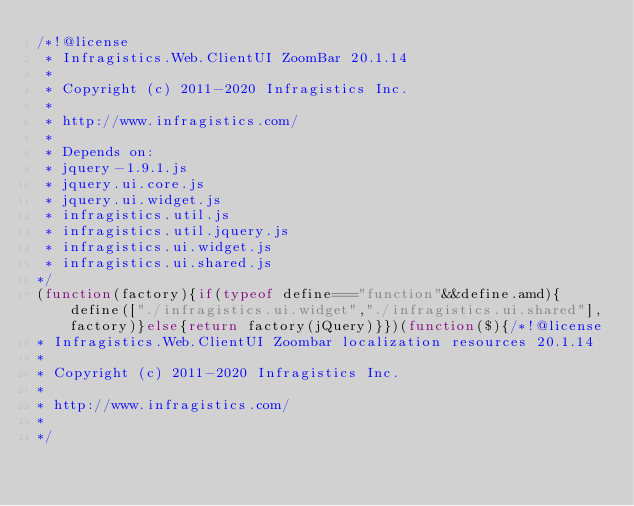Convert code to text. <code><loc_0><loc_0><loc_500><loc_500><_JavaScript_>/*!@license
 * Infragistics.Web.ClientUI ZoomBar 20.1.14
 *
 * Copyright (c) 2011-2020 Infragistics Inc.
 *
 * http://www.infragistics.com/
 *
 * Depends on:
 * jquery-1.9.1.js
 * jquery.ui.core.js
 * jquery.ui.widget.js
 * infragistics.util.js
 * infragistics.util.jquery.js
 * infragistics.ui.widget.js
 * infragistics.ui.shared.js
*/
(function(factory){if(typeof define==="function"&&define.amd){define(["./infragistics.ui.widget","./infragistics.ui.shared"],factory)}else{return factory(jQuery)}})(function($){/*!@license
* Infragistics.Web.ClientUI Zoombar localization resources 20.1.14
*
* Copyright (c) 2011-2020 Infragistics Inc.
*
* http://www.infragistics.com/
*
*/</code> 